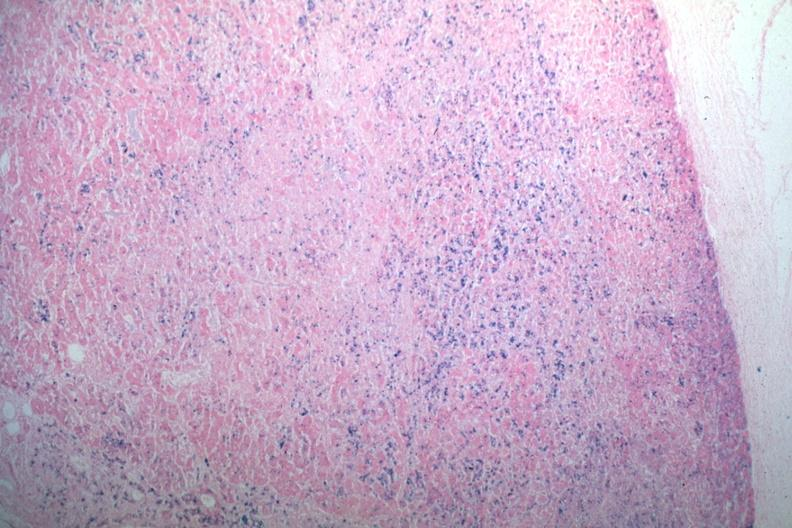does this image show iron stain abundant iron?
Answer the question using a single word or phrase. Yes 